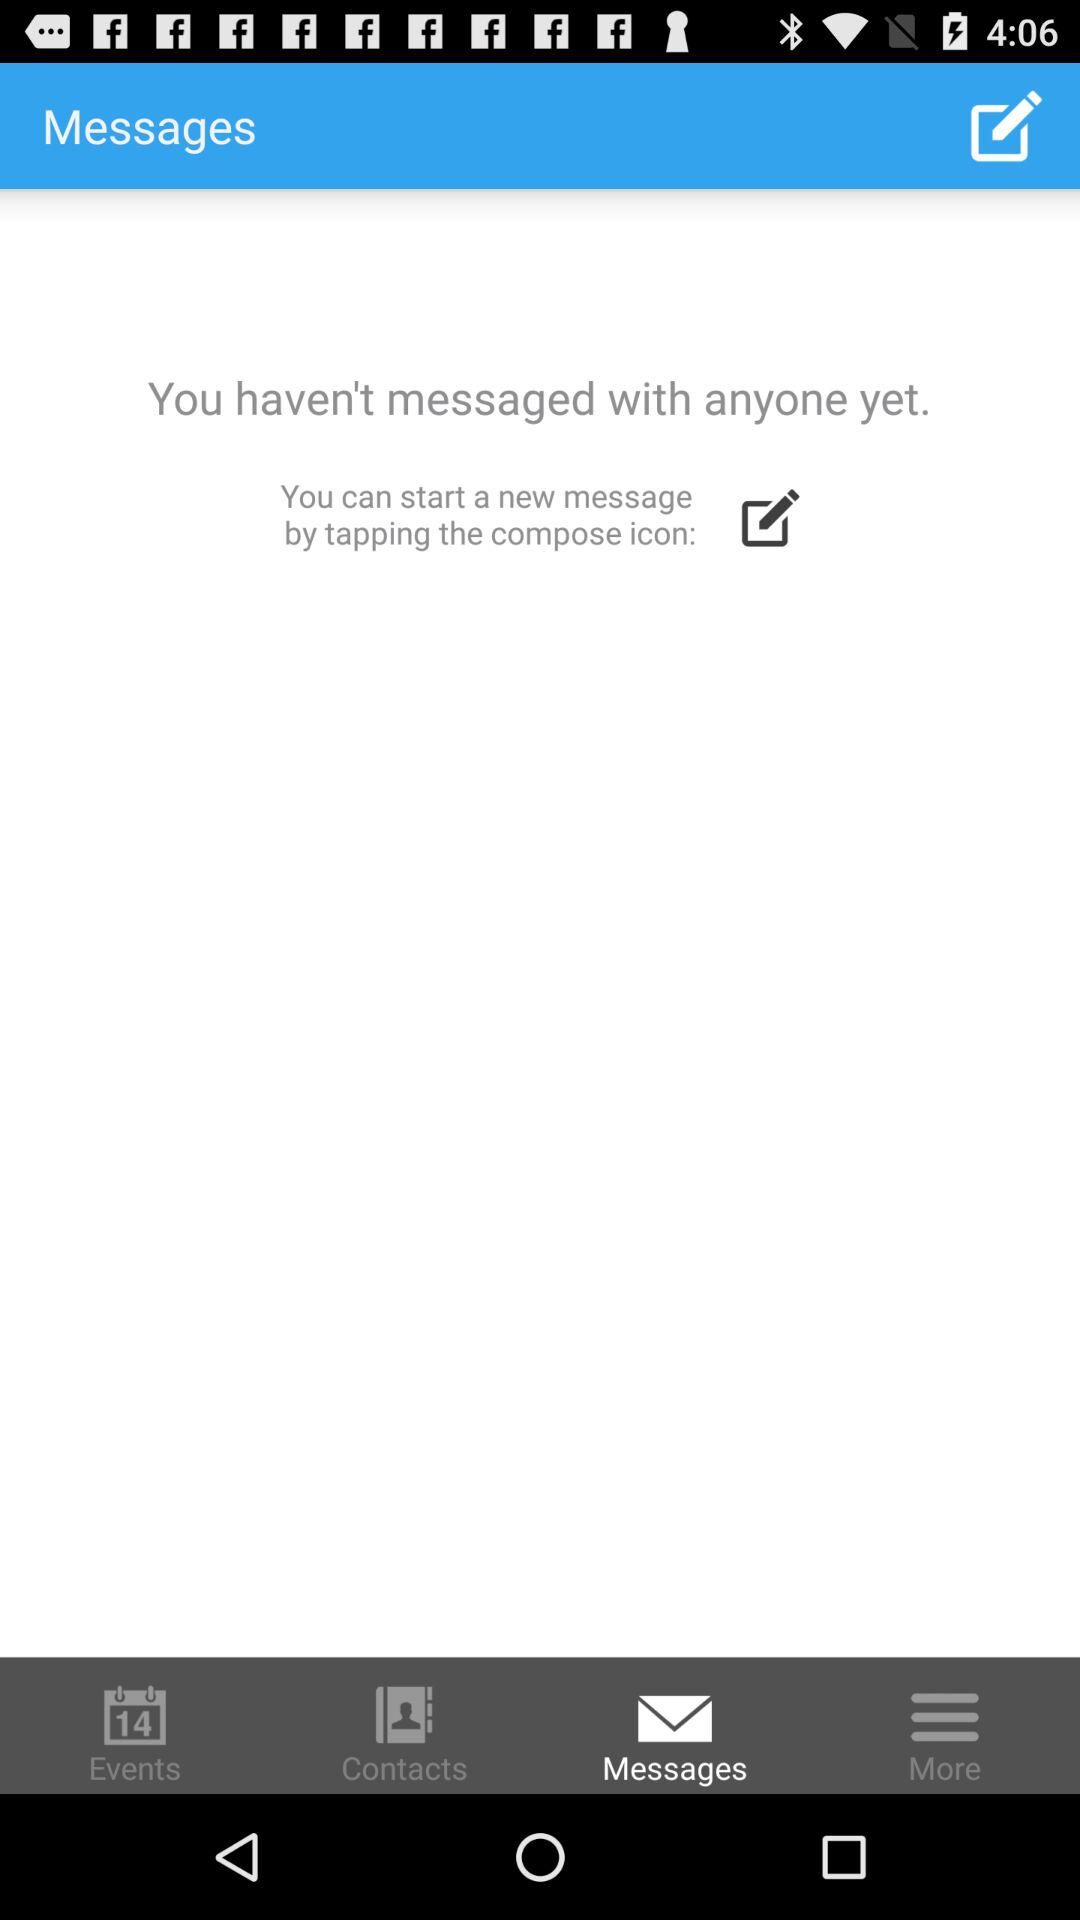How many messages have I sent?
Answer the question using a single word or phrase. 0 